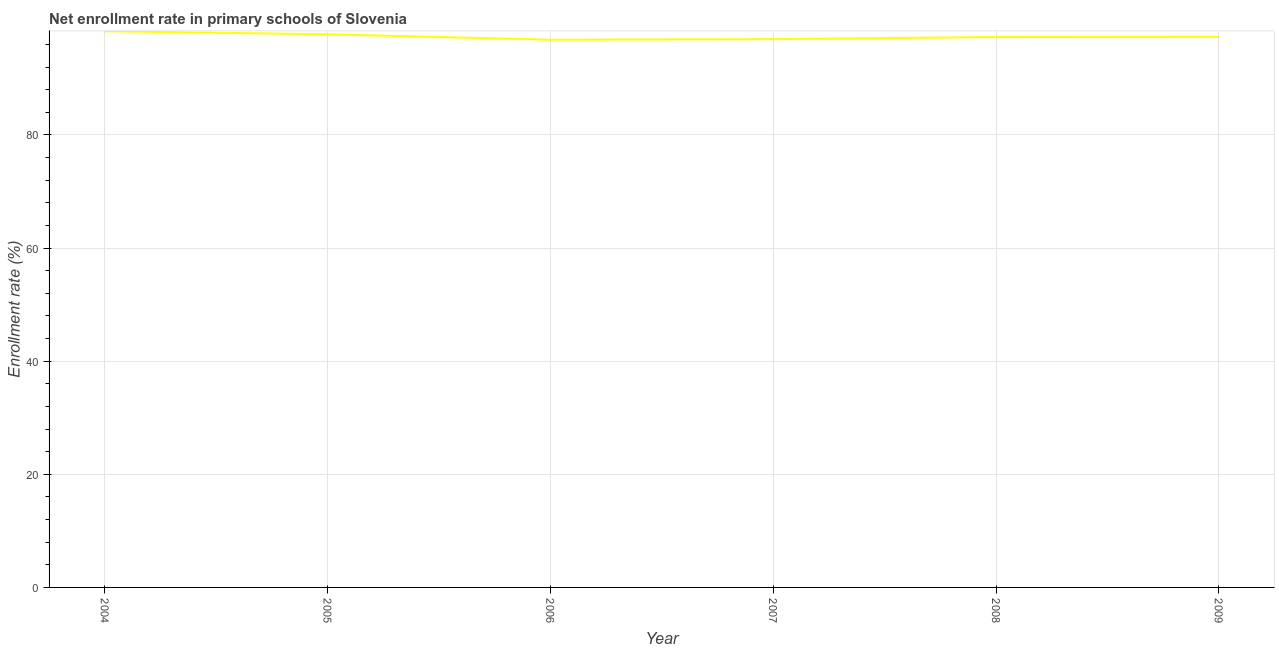What is the net enrollment rate in primary schools in 2005?
Your answer should be compact. 97.8. Across all years, what is the maximum net enrollment rate in primary schools?
Give a very brief answer. 98.34. Across all years, what is the minimum net enrollment rate in primary schools?
Provide a short and direct response. 96.84. What is the sum of the net enrollment rate in primary schools?
Your answer should be very brief. 584.59. What is the difference between the net enrollment rate in primary schools in 2006 and 2007?
Provide a succinct answer. -0.1. What is the average net enrollment rate in primary schools per year?
Give a very brief answer. 97.43. What is the median net enrollment rate in primary schools?
Ensure brevity in your answer.  97.34. In how many years, is the net enrollment rate in primary schools greater than 60 %?
Offer a very short reply. 6. Do a majority of the years between 2007 and 2008 (inclusive) have net enrollment rate in primary schools greater than 88 %?
Keep it short and to the point. Yes. What is the ratio of the net enrollment rate in primary schools in 2006 to that in 2007?
Offer a very short reply. 1. Is the difference between the net enrollment rate in primary schools in 2004 and 2007 greater than the difference between any two years?
Ensure brevity in your answer.  No. What is the difference between the highest and the second highest net enrollment rate in primary schools?
Give a very brief answer. 0.53. What is the difference between the highest and the lowest net enrollment rate in primary schools?
Your answer should be very brief. 1.5. How many lines are there?
Your response must be concise. 1. How many years are there in the graph?
Ensure brevity in your answer.  6. What is the difference between two consecutive major ticks on the Y-axis?
Give a very brief answer. 20. Are the values on the major ticks of Y-axis written in scientific E-notation?
Give a very brief answer. No. Does the graph contain any zero values?
Ensure brevity in your answer.  No. What is the title of the graph?
Provide a short and direct response. Net enrollment rate in primary schools of Slovenia. What is the label or title of the X-axis?
Provide a succinct answer. Year. What is the label or title of the Y-axis?
Provide a short and direct response. Enrollment rate (%). What is the Enrollment rate (%) in 2004?
Offer a terse response. 98.34. What is the Enrollment rate (%) of 2005?
Give a very brief answer. 97.8. What is the Enrollment rate (%) of 2006?
Provide a short and direct response. 96.84. What is the Enrollment rate (%) of 2007?
Provide a succinct answer. 96.94. What is the Enrollment rate (%) in 2008?
Your response must be concise. 97.31. What is the Enrollment rate (%) of 2009?
Make the answer very short. 97.36. What is the difference between the Enrollment rate (%) in 2004 and 2005?
Offer a terse response. 0.53. What is the difference between the Enrollment rate (%) in 2004 and 2006?
Offer a very short reply. 1.5. What is the difference between the Enrollment rate (%) in 2004 and 2007?
Provide a succinct answer. 1.4. What is the difference between the Enrollment rate (%) in 2004 and 2008?
Provide a short and direct response. 1.02. What is the difference between the Enrollment rate (%) in 2004 and 2009?
Give a very brief answer. 0.98. What is the difference between the Enrollment rate (%) in 2005 and 2006?
Keep it short and to the point. 0.97. What is the difference between the Enrollment rate (%) in 2005 and 2007?
Offer a very short reply. 0.87. What is the difference between the Enrollment rate (%) in 2005 and 2008?
Make the answer very short. 0.49. What is the difference between the Enrollment rate (%) in 2005 and 2009?
Provide a short and direct response. 0.45. What is the difference between the Enrollment rate (%) in 2006 and 2007?
Provide a succinct answer. -0.1. What is the difference between the Enrollment rate (%) in 2006 and 2008?
Your answer should be very brief. -0.48. What is the difference between the Enrollment rate (%) in 2006 and 2009?
Make the answer very short. -0.52. What is the difference between the Enrollment rate (%) in 2007 and 2008?
Your answer should be compact. -0.38. What is the difference between the Enrollment rate (%) in 2007 and 2009?
Provide a short and direct response. -0.42. What is the difference between the Enrollment rate (%) in 2008 and 2009?
Provide a succinct answer. -0.04. What is the ratio of the Enrollment rate (%) in 2004 to that in 2007?
Offer a very short reply. 1.01. What is the ratio of the Enrollment rate (%) in 2004 to that in 2008?
Your answer should be very brief. 1.01. What is the ratio of the Enrollment rate (%) in 2005 to that in 2006?
Make the answer very short. 1.01. What is the ratio of the Enrollment rate (%) in 2005 to that in 2009?
Give a very brief answer. 1. What is the ratio of the Enrollment rate (%) in 2006 to that in 2007?
Provide a succinct answer. 1. What is the ratio of the Enrollment rate (%) in 2006 to that in 2008?
Your answer should be very brief. 0.99. What is the ratio of the Enrollment rate (%) in 2007 to that in 2009?
Provide a succinct answer. 1. 